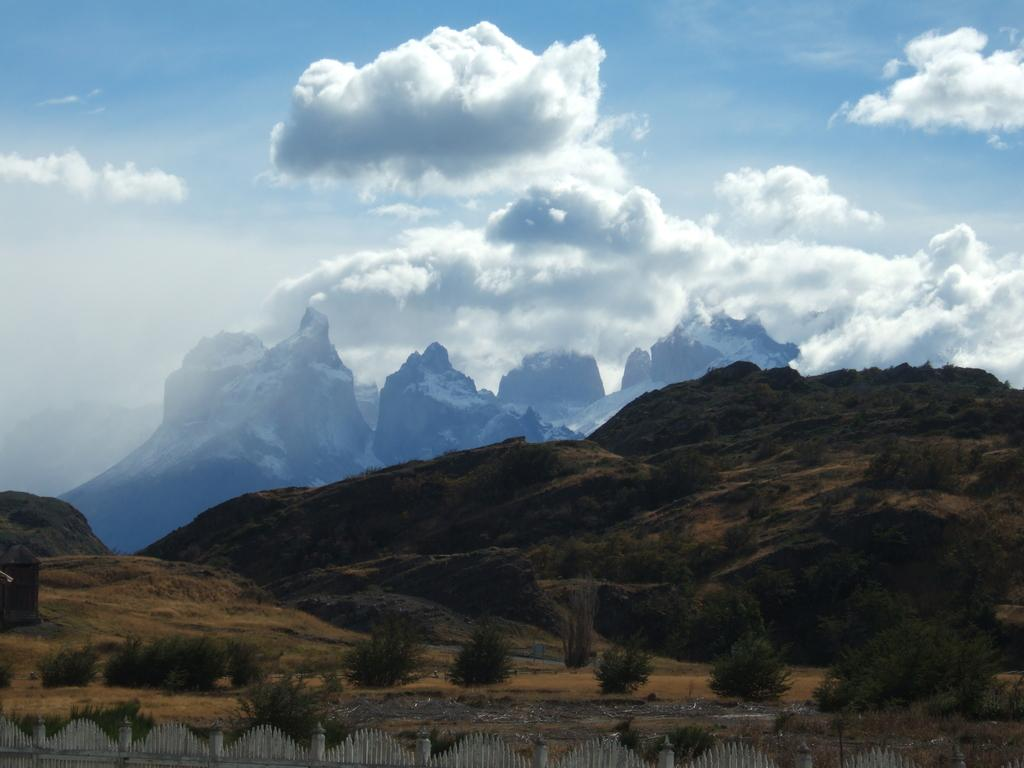What type of landscape is depicted in the image? The image features hills and trees. What other vegetation can be seen in the image? There are plants in the image. What is located at the bottom of the image? There is fencing at the bottom of the image. What is visible in the background of the image? The sky is visible in the background of the image, and it appears to be cloudy. What type of beast is depicted in the image? There is no beast present in the image; it features hills, trees, plants, fencing, and a cloudy sky. What type of flesh can be seen in the image? There is no flesh present in the image; it is a landscape scene with hills, trees, plants, fencing, and a cloudy sky. 